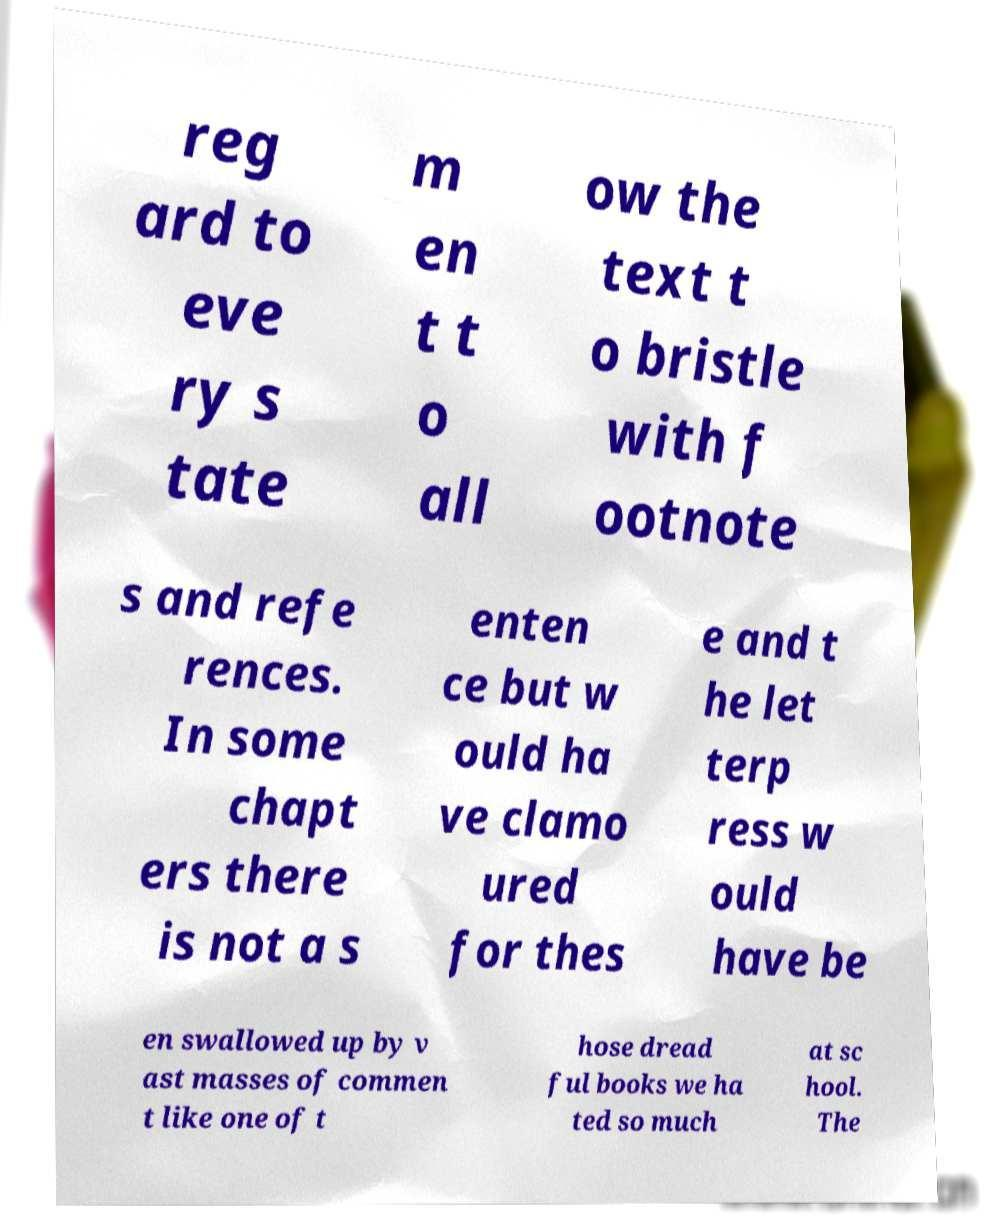Can you accurately transcribe the text from the provided image for me? reg ard to eve ry s tate m en t t o all ow the text t o bristle with f ootnote s and refe rences. In some chapt ers there is not a s enten ce but w ould ha ve clamo ured for thes e and t he let terp ress w ould have be en swallowed up by v ast masses of commen t like one of t hose dread ful books we ha ted so much at sc hool. The 